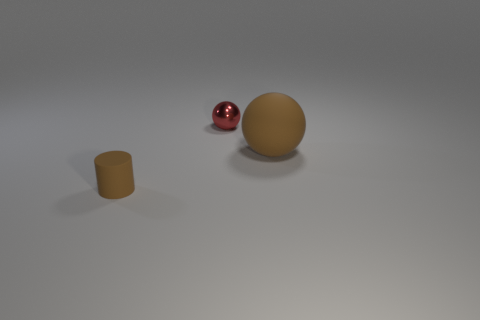Add 1 small cylinders. How many objects exist? 4 Subtract all spheres. How many objects are left? 1 Add 2 large matte spheres. How many large matte spheres are left? 3 Add 3 tiny shiny balls. How many tiny shiny balls exist? 4 Subtract 0 gray spheres. How many objects are left? 3 Subtract all small things. Subtract all tiny yellow matte cylinders. How many objects are left? 1 